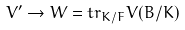Convert formula to latex. <formula><loc_0><loc_0><loc_500><loc_500>V ^ { \prime } \rightarrow W = t r _ { K / F } V ( B / K )</formula> 